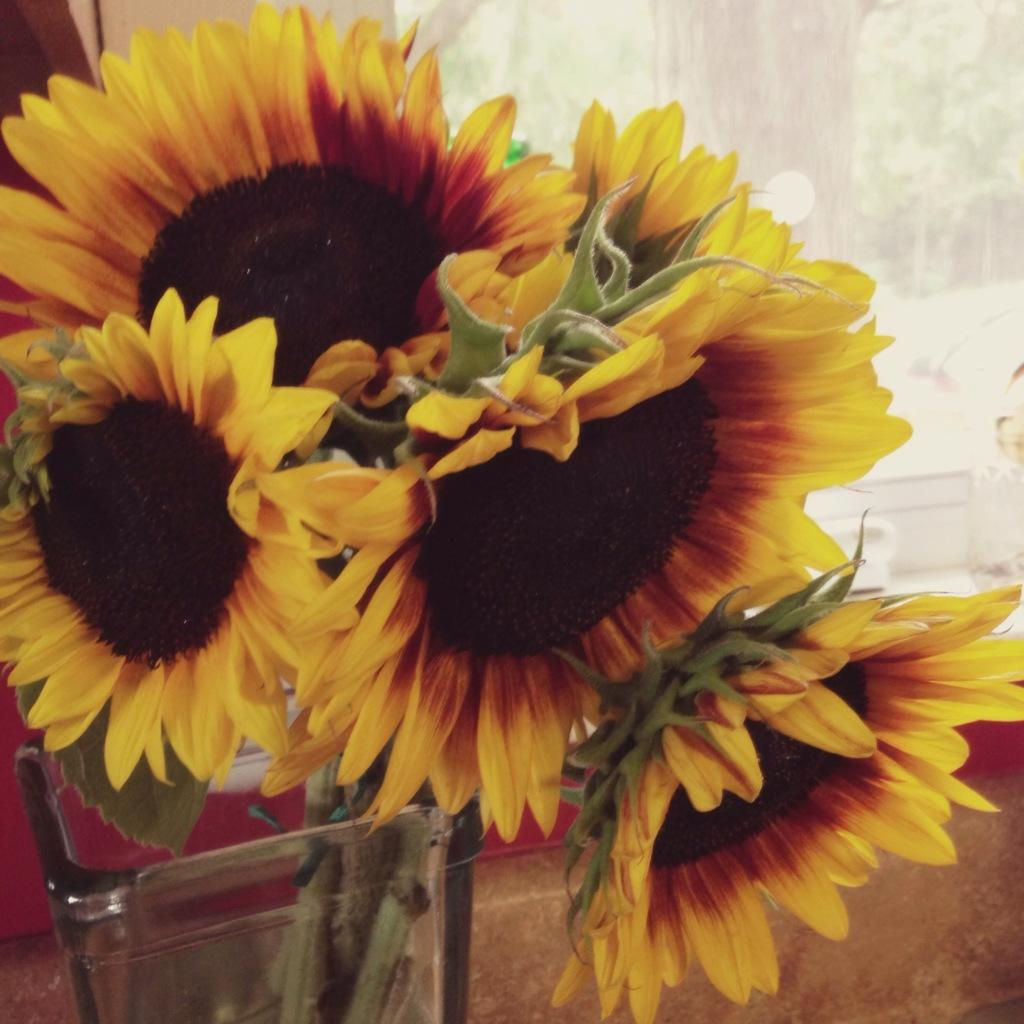What type of flowers are in the image? There are sunflowers in the image. How are the sunflowers contained in the image? The sunflowers are in a glass jar. Can you describe the background of the image? The background of the image is blurred. What type of exchange is taking place on the roof in the image? There is no exchange or roof present in the image; it features sunflowers in a glass jar with a blurred background. 